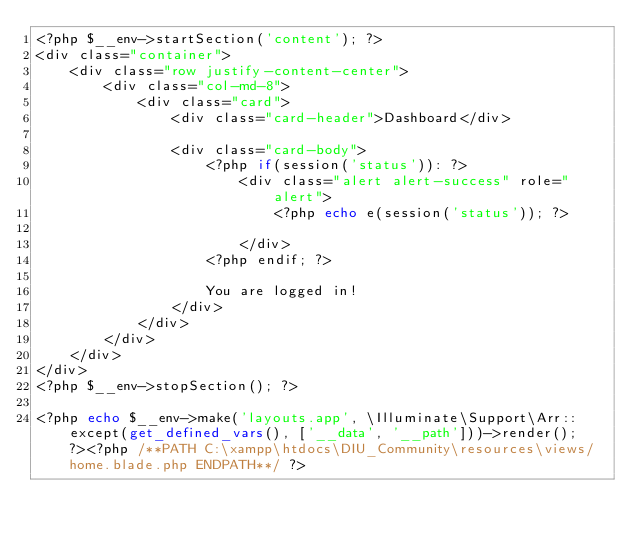<code> <loc_0><loc_0><loc_500><loc_500><_PHP_><?php $__env->startSection('content'); ?>
<div class="container">
    <div class="row justify-content-center">
        <div class="col-md-8">
            <div class="card">
                <div class="card-header">Dashboard</div>

                <div class="card-body">
                    <?php if(session('status')): ?>
                        <div class="alert alert-success" role="alert">
                            <?php echo e(session('status')); ?>

                        </div>
                    <?php endif; ?>

                    You are logged in!
                </div>
            </div>
        </div>
    </div>
</div>
<?php $__env->stopSection(); ?>

<?php echo $__env->make('layouts.app', \Illuminate\Support\Arr::except(get_defined_vars(), ['__data', '__path']))->render(); ?><?php /**PATH C:\xampp\htdocs\DIU_Community\resources\views/home.blade.php ENDPATH**/ ?></code> 